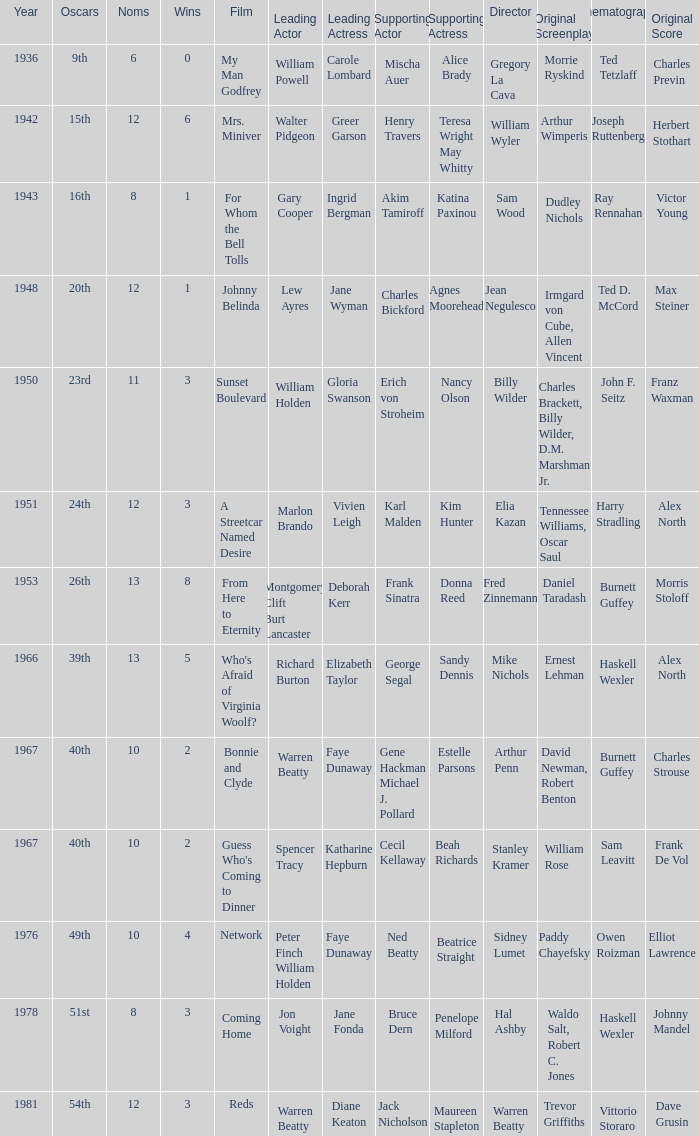Who was the leading actress in a film with Warren Beatty as the leading actor and also at the 40th Oscars? Faye Dunaway. 